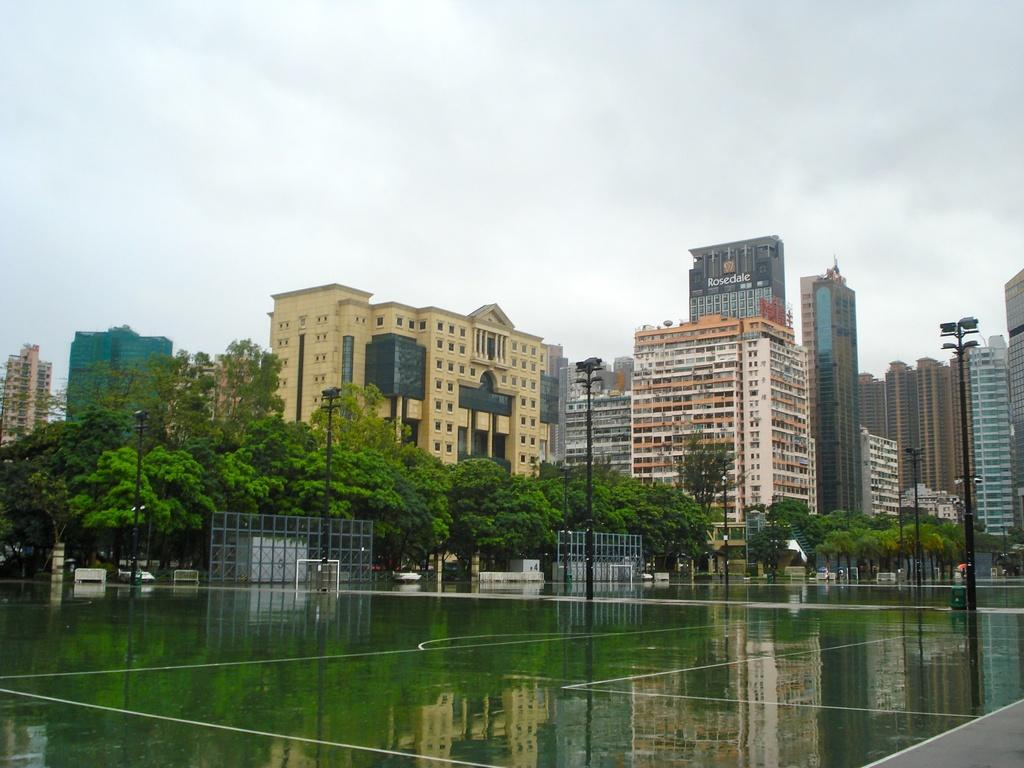What can be seen in the center of the image? The center of the image contains the sky, clouds, buildings, trees, and poles. What natural element is visible in the image? There is water visible in the image. Where is the text located in the image? The text is located at the bottom right side of the image. How many mice are playing musical instruments in the image? There are no mice or musical instruments present in the image. What message is conveyed by the note in the image? There is no note present in the image; only text is mentioned at the bottom right side. 